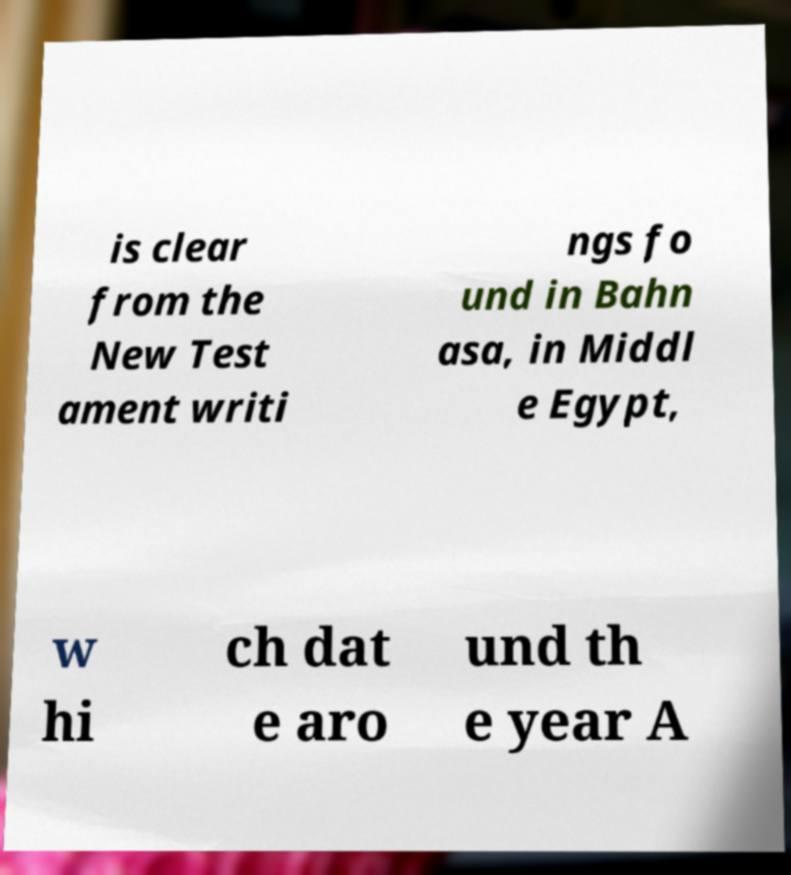For documentation purposes, I need the text within this image transcribed. Could you provide that? is clear from the New Test ament writi ngs fo und in Bahn asa, in Middl e Egypt, w hi ch dat e aro und th e year A 